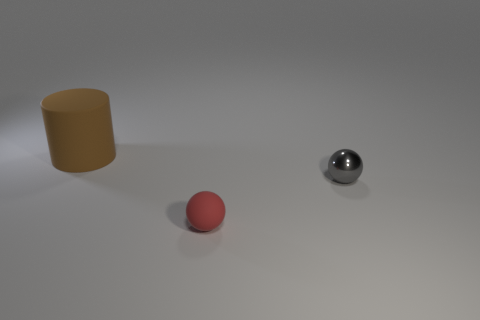Is there any other thing that has the same shape as the brown rubber object?
Your answer should be very brief. No. What number of things are either big cylinders or large purple objects?
Ensure brevity in your answer.  1. There is another sphere that is the same size as the gray metal sphere; what is it made of?
Your response must be concise. Rubber. There is a sphere behind the rubber sphere; what size is it?
Ensure brevity in your answer.  Small. What is the material of the cylinder?
Offer a terse response. Rubber. How many objects are balls in front of the metal object or objects on the right side of the large matte object?
Your response must be concise. 2. How many other things are there of the same color as the large rubber cylinder?
Provide a short and direct response. 0. There is a red rubber object; is its shape the same as the large brown rubber thing behind the gray shiny object?
Keep it short and to the point. No. Are there fewer big brown rubber cylinders that are in front of the tiny rubber ball than red balls that are behind the big brown matte cylinder?
Your answer should be very brief. No. There is another tiny thing that is the same shape as the small red thing; what is it made of?
Offer a very short reply. Metal. 